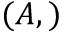Convert formula to latex. <formula><loc_0><loc_0><loc_500><loc_500>( A , )</formula> 